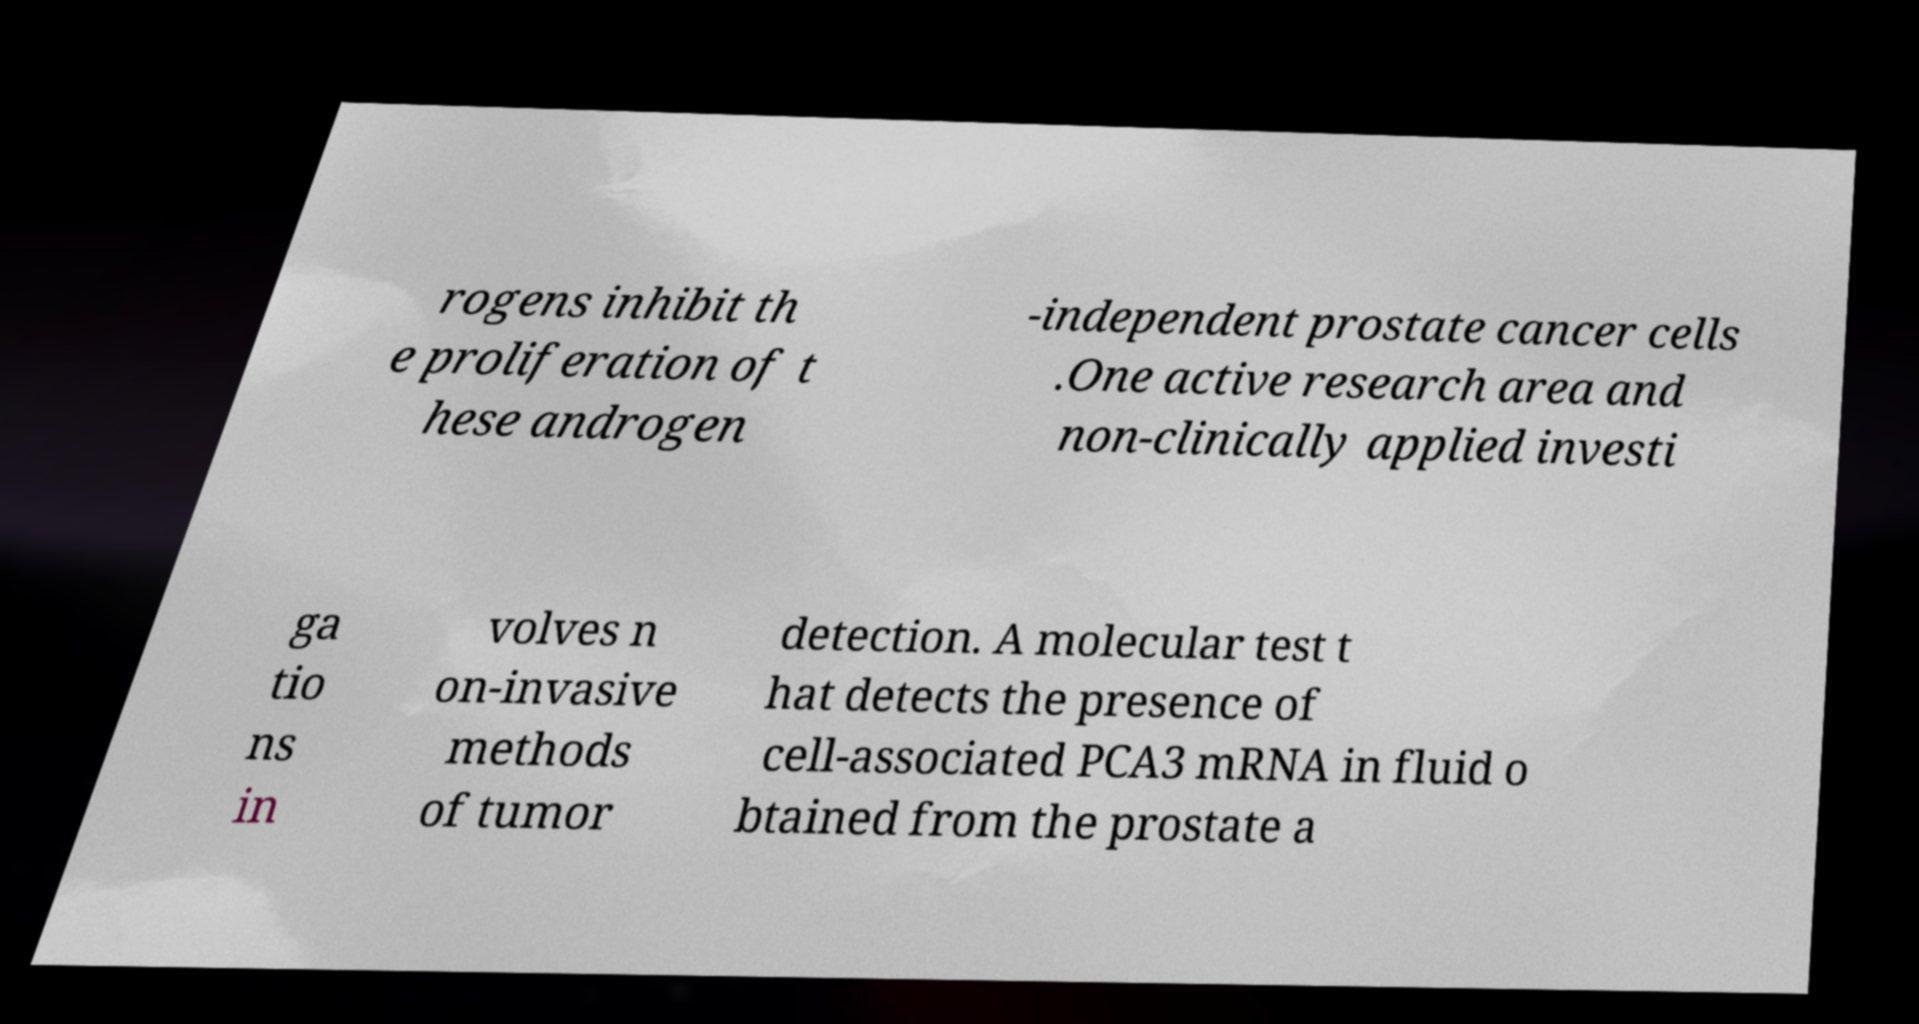I need the written content from this picture converted into text. Can you do that? rogens inhibit th e proliferation of t hese androgen -independent prostate cancer cells .One active research area and non-clinically applied investi ga tio ns in volves n on-invasive methods of tumor detection. A molecular test t hat detects the presence of cell-associated PCA3 mRNA in fluid o btained from the prostate a 